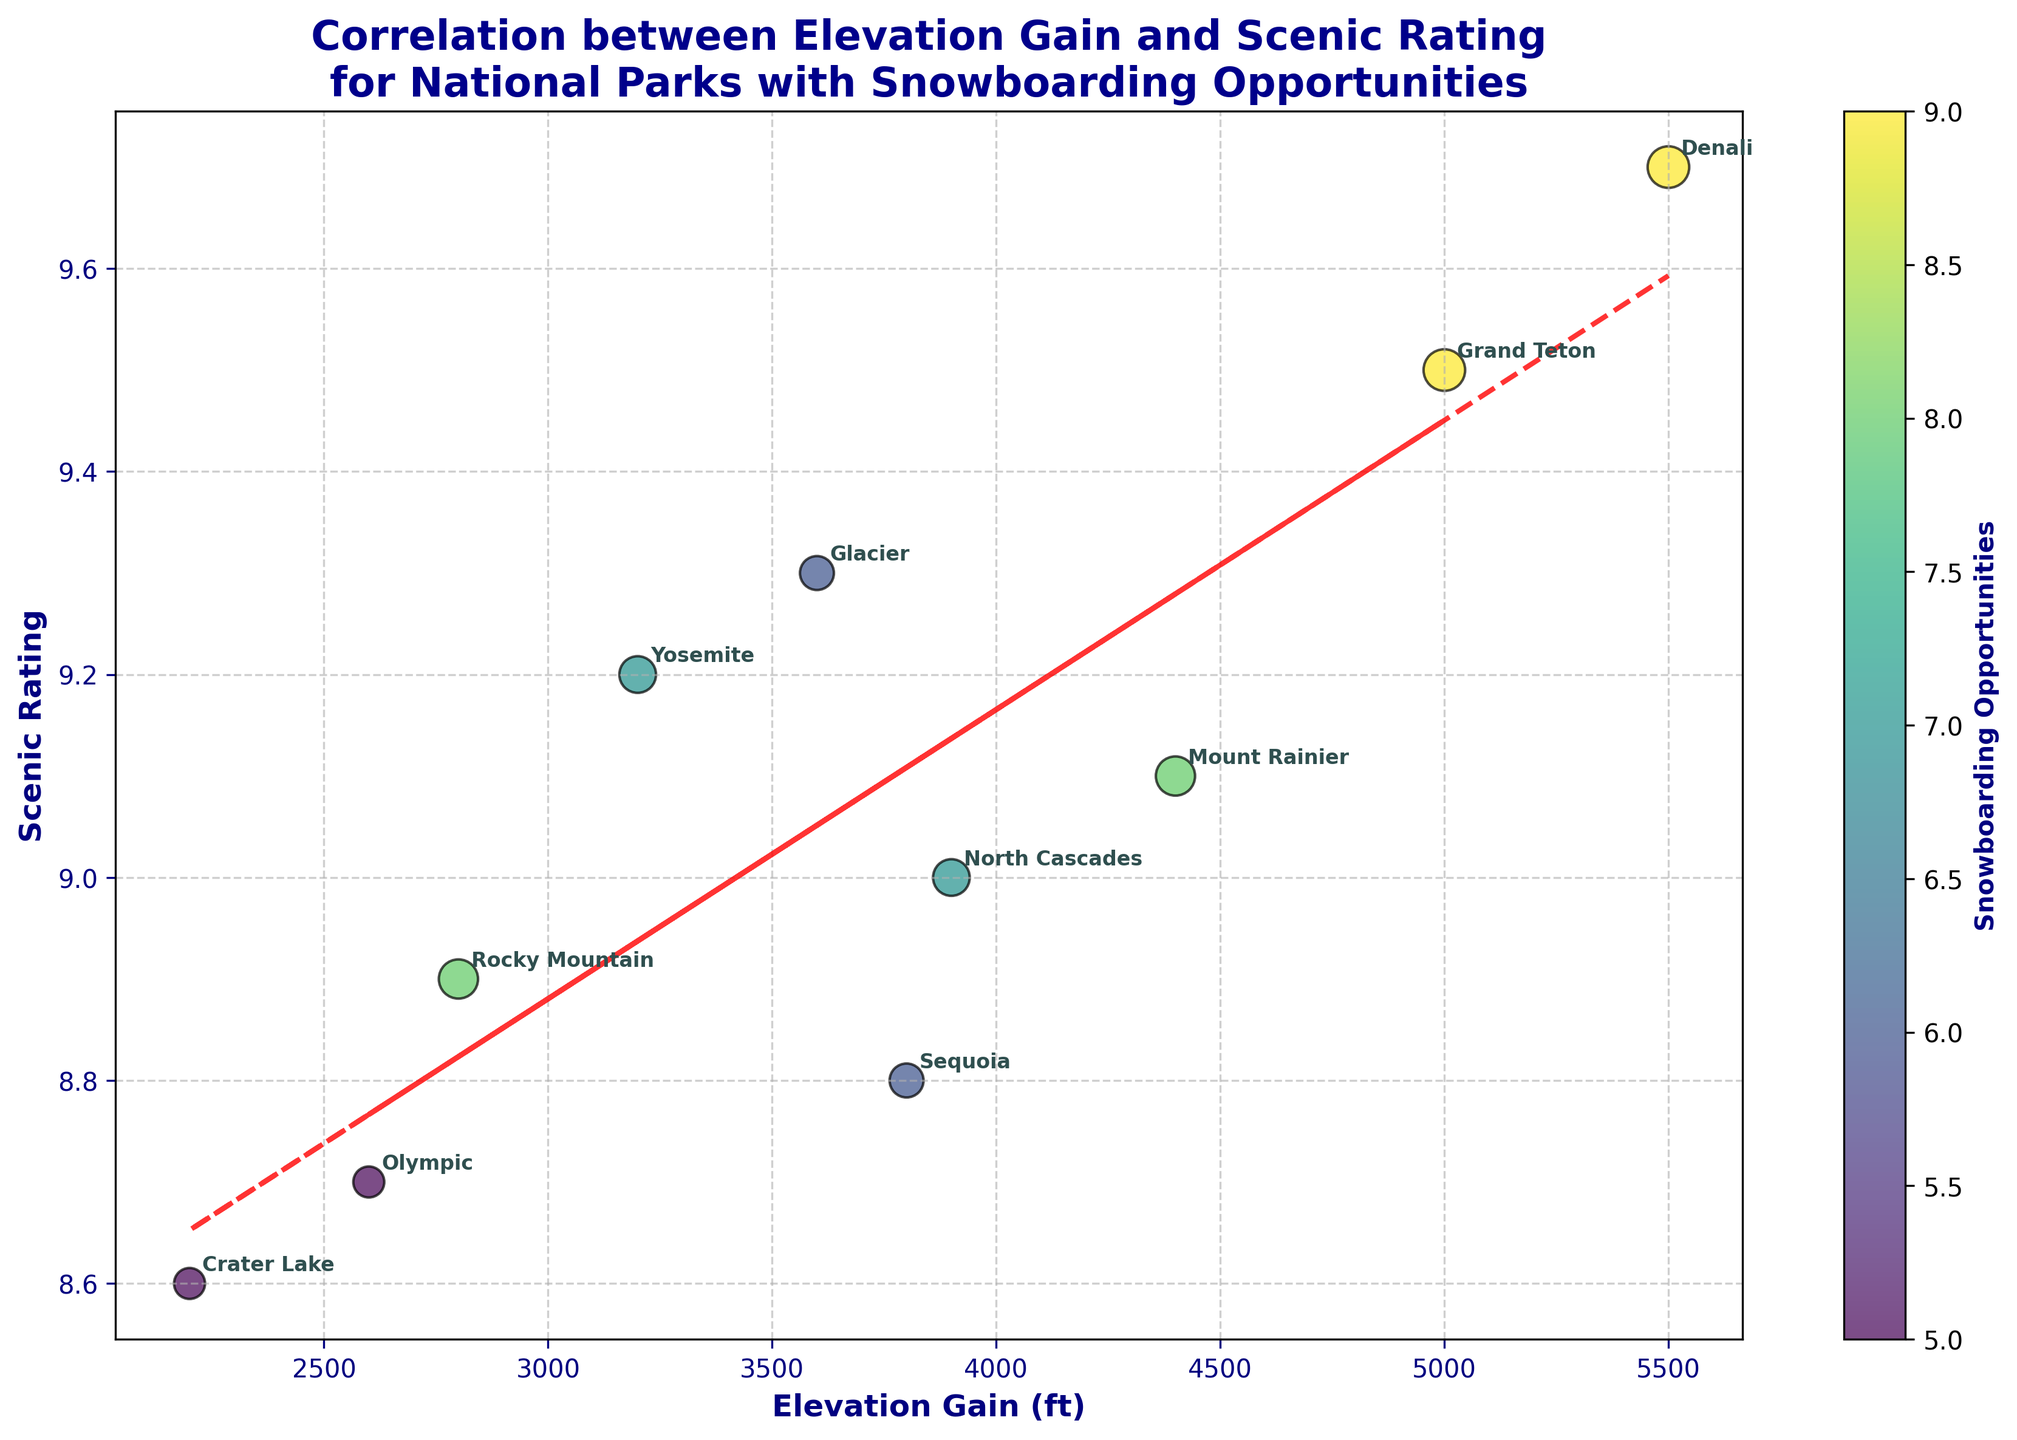How many national parks are represented in the plot? Count the number of data points (labels) in the scatter plot. Each point represents a national park.
Answer: 10 What color scale is used to represent the number of snowboarding opportunities? Observe the color of the scatter points and refer to the color bar. The color bar shows different shades from light green to dark purple, which corresponds to fewer to more snowboarding opportunities.
Answer: Viridis Which national park has the highest elevation gain? Locate the point on the x-axis with the highest value and read its corresponding label.
Answer: Denali What is the scenic rating of Yosemite? Find the label "Yosemite" on the plot and read off its corresponding y-axis value.
Answer: 9.2 How does the elevation gain of Grand Teton compare to that of Glacier? Locate both "Grand Teton" and "Glacier" on the x-axis and compare their elevation gains. Grand Teton's position on the x-axis is higher than that of Glacier.
Answer: Grand Teton has a higher elevation gain Which park has the lowest scenic rating, and what is that rating? Identify the park with the smallest y-axis value by locating the lowest point on the vertical scale and noting its label and rating.
Answer: Crater Lake, 8.6 Are there any parks with both high scenic rating and high snowboarding opportunities? Observe the points that have both a high y-axis value (scenic rating) and a darker color (higher snowboarding opportunities).
Answer: Denali and Grand Teton Is there a positive relationship between elevation gain and scenic rating? Look at the trend line added to the scatter plot. A positive slope indicates a positive relationship. The trend line slopes upwards, indicating a positive correlation.
Answer: Yes Which park has the lowest number of snowboarding opportunities, and what is its scenic rating? Identify the point with the lightest color and note its label and corresponding y-axis value.
Answer: Crater Lake, 8.6 What is the average scenic rating for the national parks? Sum all the scenic ratings and divide by the number of national parks. Ratings: 9.2, 9.5, 8.9, 9.1, 9.3, 8.7, 8.8, 9.0, 8.6, 9.7. (9.2 + 9.5 + 8.9 + 9.1 + 9.3 + 8.7 + 8.8 + 9.0 + 8.6 + 9.7) / 10 = 90.8 / 10 = 9.08
Answer: 9.08 